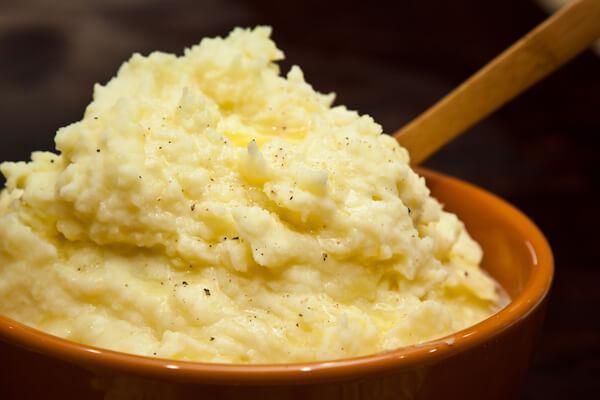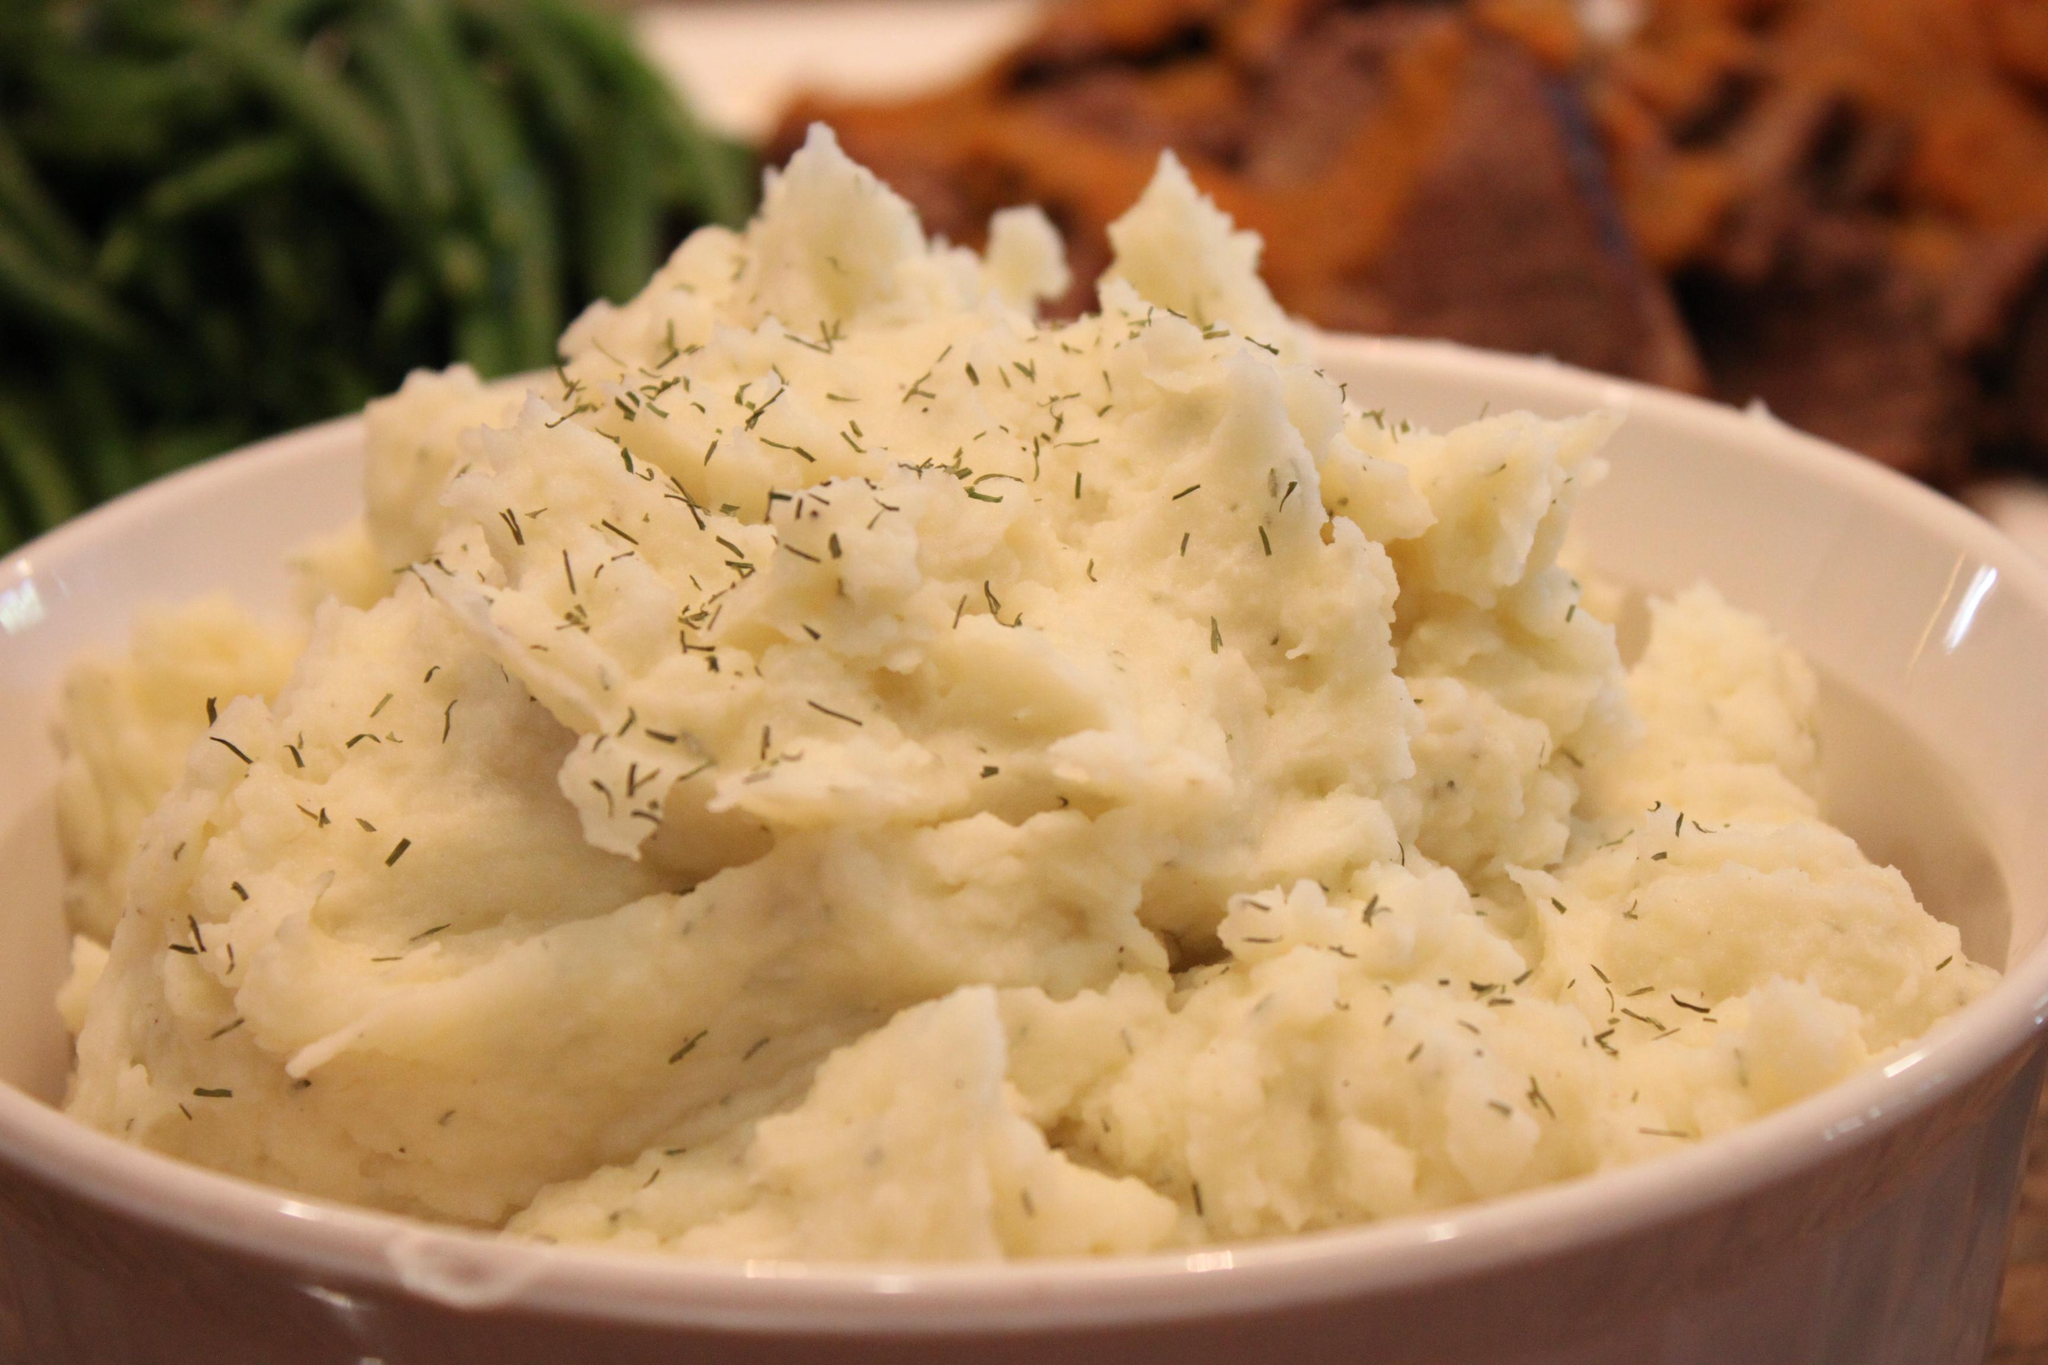The first image is the image on the left, the second image is the image on the right. For the images displayed, is the sentence "In one image, mashed potatoes are served on a plate with a vegetable and a meat or fish course, while a second image shows mashed potatoes with flecks of chive." factually correct? Answer yes or no. No. The first image is the image on the left, the second image is the image on the right. For the images displayed, is the sentence "There are cut vegetables next to a mashed potato on a plate  in the left image." factually correct? Answer yes or no. No. 